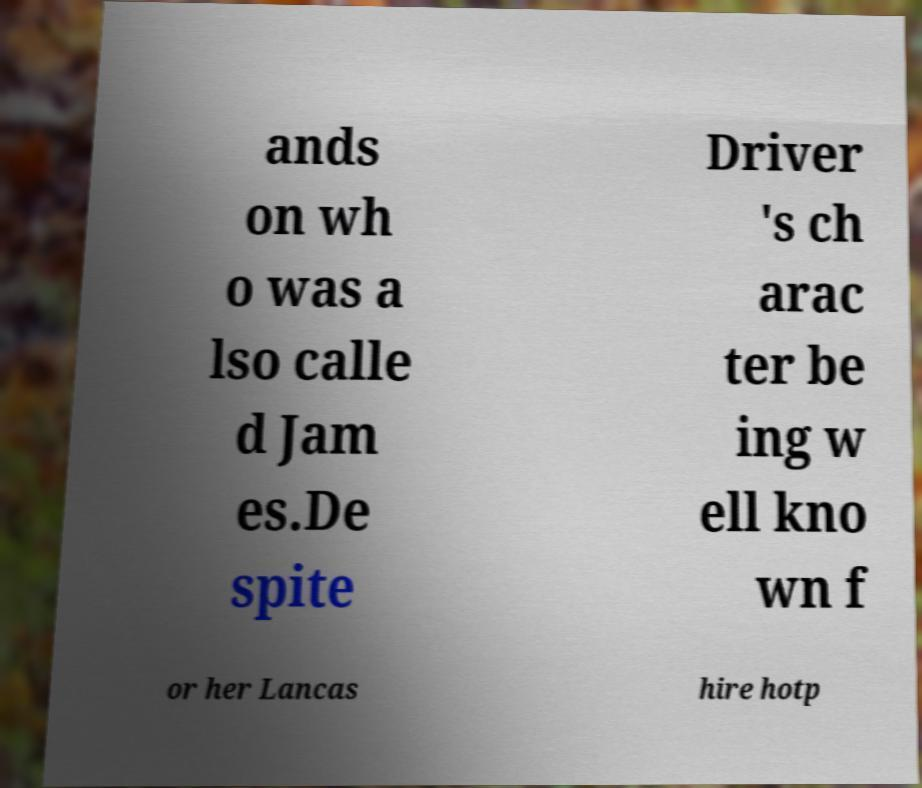What messages or text are displayed in this image? I need them in a readable, typed format. ands on wh o was a lso calle d Jam es.De spite Driver 's ch arac ter be ing w ell kno wn f or her Lancas hire hotp 